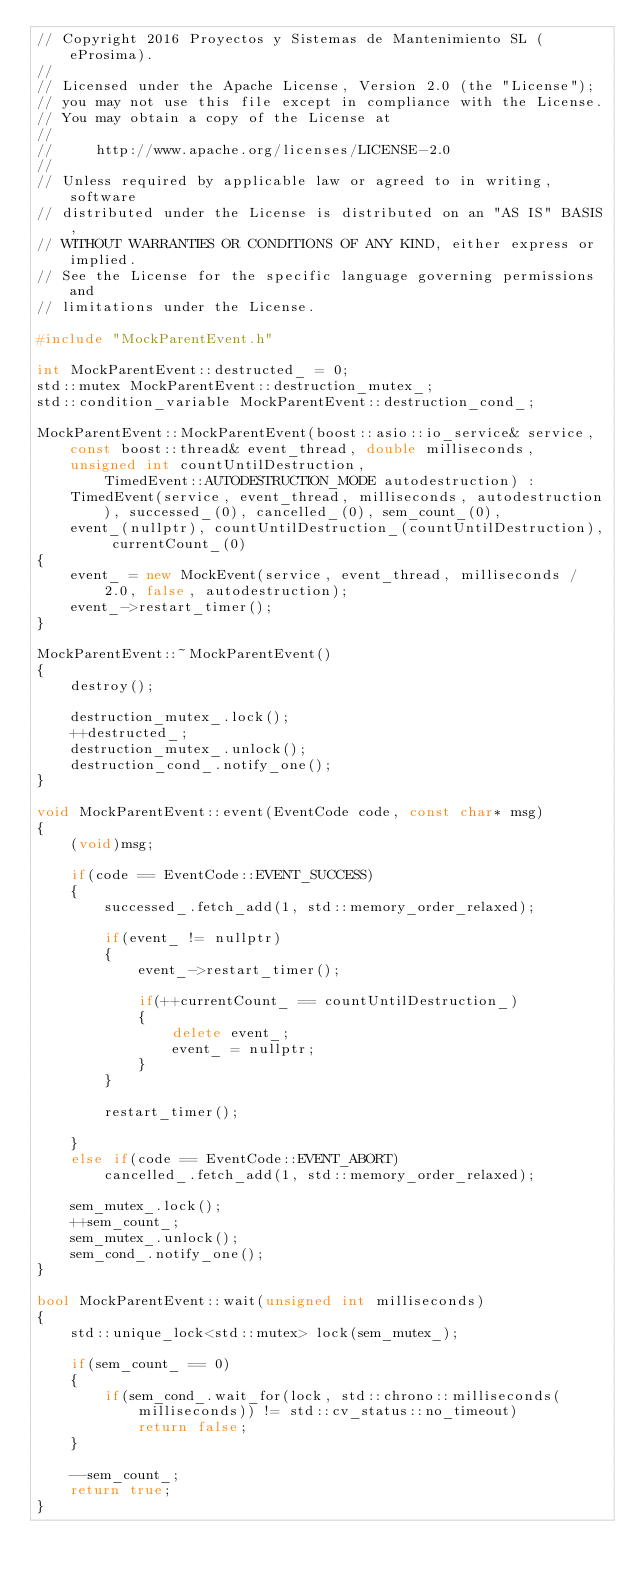Convert code to text. <code><loc_0><loc_0><loc_500><loc_500><_C++_>// Copyright 2016 Proyectos y Sistemas de Mantenimiento SL (eProsima).
//
// Licensed under the Apache License, Version 2.0 (the "License");
// you may not use this file except in compliance with the License.
// You may obtain a copy of the License at
//
//     http://www.apache.org/licenses/LICENSE-2.0
//
// Unless required by applicable law or agreed to in writing, software
// distributed under the License is distributed on an "AS IS" BASIS,
// WITHOUT WARRANTIES OR CONDITIONS OF ANY KIND, either express or implied.
// See the License for the specific language governing permissions and
// limitations under the License.

#include "MockParentEvent.h"

int MockParentEvent::destructed_ = 0;
std::mutex MockParentEvent::destruction_mutex_;
std::condition_variable MockParentEvent::destruction_cond_;

MockParentEvent::MockParentEvent(boost::asio::io_service& service, const boost::thread& event_thread, double milliseconds, unsigned int countUntilDestruction,
        TimedEvent::AUTODESTRUCTION_MODE autodestruction) : 
    TimedEvent(service, event_thread, milliseconds, autodestruction), successed_(0), cancelled_(0), sem_count_(0),
    event_(nullptr), countUntilDestruction_(countUntilDestruction), currentCount_(0)
{
    event_ = new MockEvent(service, event_thread, milliseconds / 2.0, false, autodestruction);
    event_->restart_timer();
}

MockParentEvent::~MockParentEvent()
{
    destroy();

    destruction_mutex_.lock();
    ++destructed_;
    destruction_mutex_.unlock();
    destruction_cond_.notify_one();
}

void MockParentEvent::event(EventCode code, const char* msg)
{
    (void)msg;

    if(code == EventCode::EVENT_SUCCESS)
    {
        successed_.fetch_add(1, std::memory_order_relaxed);

        if(event_ != nullptr)
        {
            event_->restart_timer();

            if(++currentCount_ == countUntilDestruction_)
            {
                delete event_;
                event_ = nullptr;
            }
        }

        restart_timer();

    }
    else if(code == EventCode::EVENT_ABORT)
        cancelled_.fetch_add(1, std::memory_order_relaxed);

    sem_mutex_.lock();
    ++sem_count_;
    sem_mutex_.unlock();
    sem_cond_.notify_one();
}

bool MockParentEvent::wait(unsigned int milliseconds)
{
    std::unique_lock<std::mutex> lock(sem_mutex_);

    if(sem_count_ == 0)
    {
        if(sem_cond_.wait_for(lock, std::chrono::milliseconds(milliseconds)) != std::cv_status::no_timeout)
            return false;
    }

    --sem_count_;
    return true;
}

</code> 